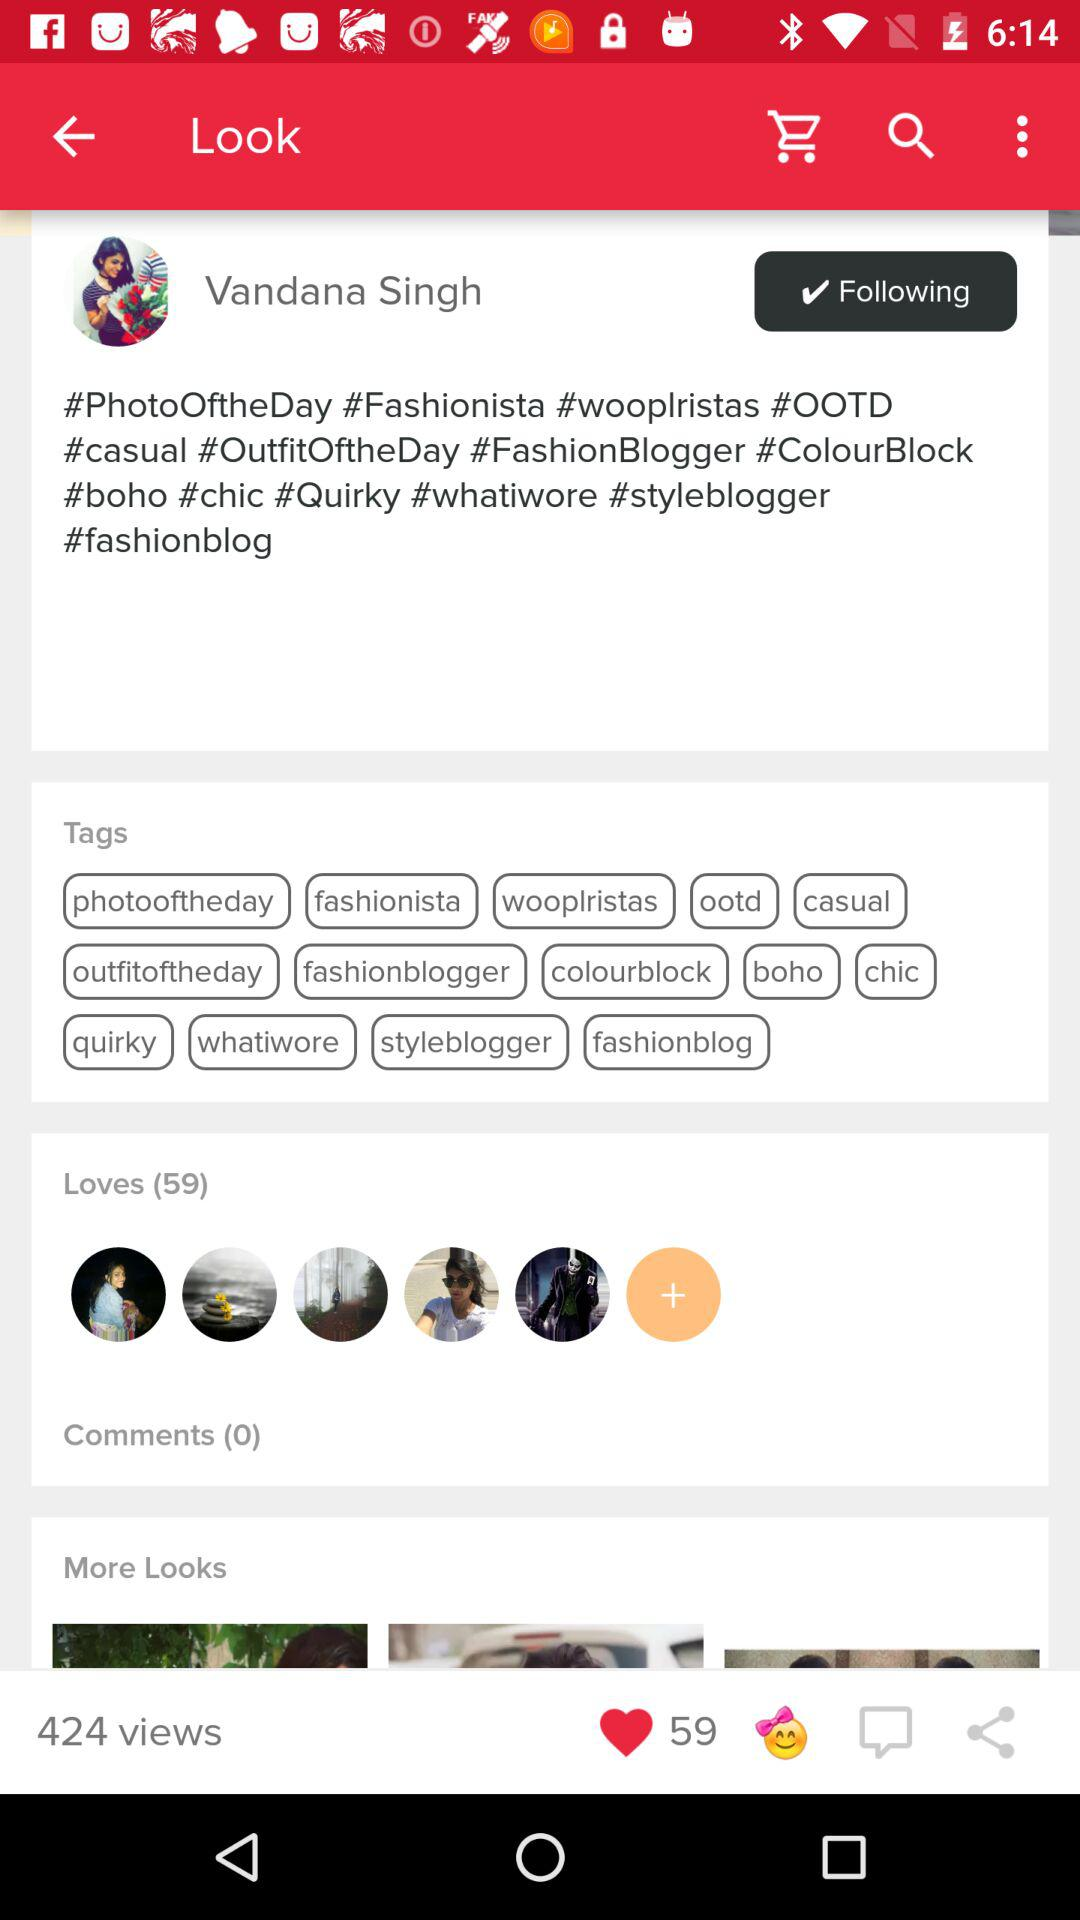How many more views are there than loves?
Answer the question using a single word or phrase. 365 